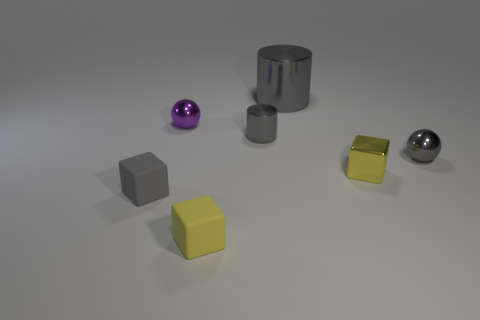Do the large object and the small cylinder have the same color?
Offer a terse response. Yes. How many things are tiny shiny cylinders or small cubes on the left side of the tiny yellow rubber cube?
Offer a terse response. 2. Are there an equal number of small shiny cylinders in front of the yellow metallic thing and tiny purple spheres?
Give a very brief answer. No. There is a small yellow thing that is made of the same material as the tiny gray block; what shape is it?
Your answer should be very brief. Cube. Are there any matte things of the same color as the tiny metallic cube?
Provide a short and direct response. Yes. What number of matte things are tiny yellow things or gray cubes?
Keep it short and to the point. 2. How many small yellow things are in front of the tiny matte object left of the yellow matte object?
Your answer should be very brief. 1. What number of purple things have the same material as the purple sphere?
Your answer should be compact. 0. What number of small things are gray shiny cylinders or purple metallic objects?
Give a very brief answer. 2. There is a gray thing that is to the left of the big thing and to the right of the tiny purple metal ball; what shape is it?
Keep it short and to the point. Cylinder. 